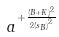<formula> <loc_0><loc_0><loc_500><loc_500>a ^ { + \frac { ( B + K ) ^ { 2 } } { 2 { ( s _ { B } ) } ^ { 2 } } }</formula> 